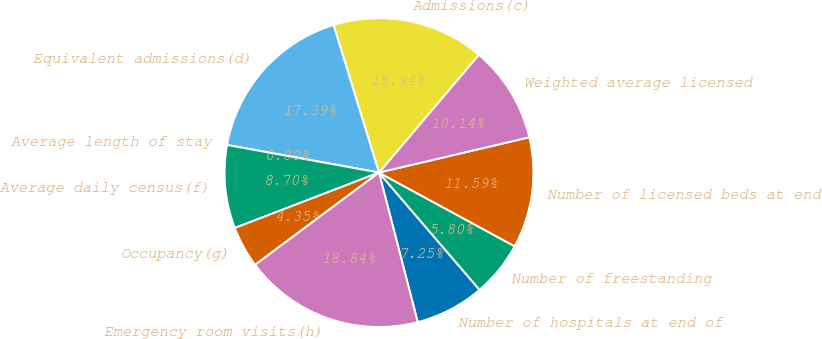Convert chart to OTSL. <chart><loc_0><loc_0><loc_500><loc_500><pie_chart><fcel>Number of hospitals at end of<fcel>Number of freestanding<fcel>Number of licensed beds at end<fcel>Weighted average licensed<fcel>Admissions(c)<fcel>Equivalent admissions(d)<fcel>Average length of stay<fcel>Average daily census(f)<fcel>Occupancy(g)<fcel>Emergency room visits(h)<nl><fcel>7.25%<fcel>5.8%<fcel>11.59%<fcel>10.14%<fcel>15.94%<fcel>17.39%<fcel>0.0%<fcel>8.7%<fcel>4.35%<fcel>18.84%<nl></chart> 